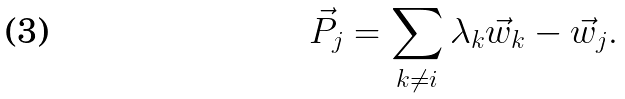Convert formula to latex. <formula><loc_0><loc_0><loc_500><loc_500>\vec { P } _ { j } = \sum _ { k \neq i } \lambda _ { k } \vec { w } _ { k } - \vec { w } _ { j } .</formula> 